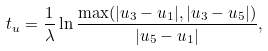<formula> <loc_0><loc_0><loc_500><loc_500>t _ { u } = \frac { 1 } { \lambda } \ln \frac { \max ( | u _ { 3 } - u _ { 1 } | , | u _ { 3 } - u _ { 5 } | ) } { | u _ { 5 } - u _ { 1 } | } ,</formula> 